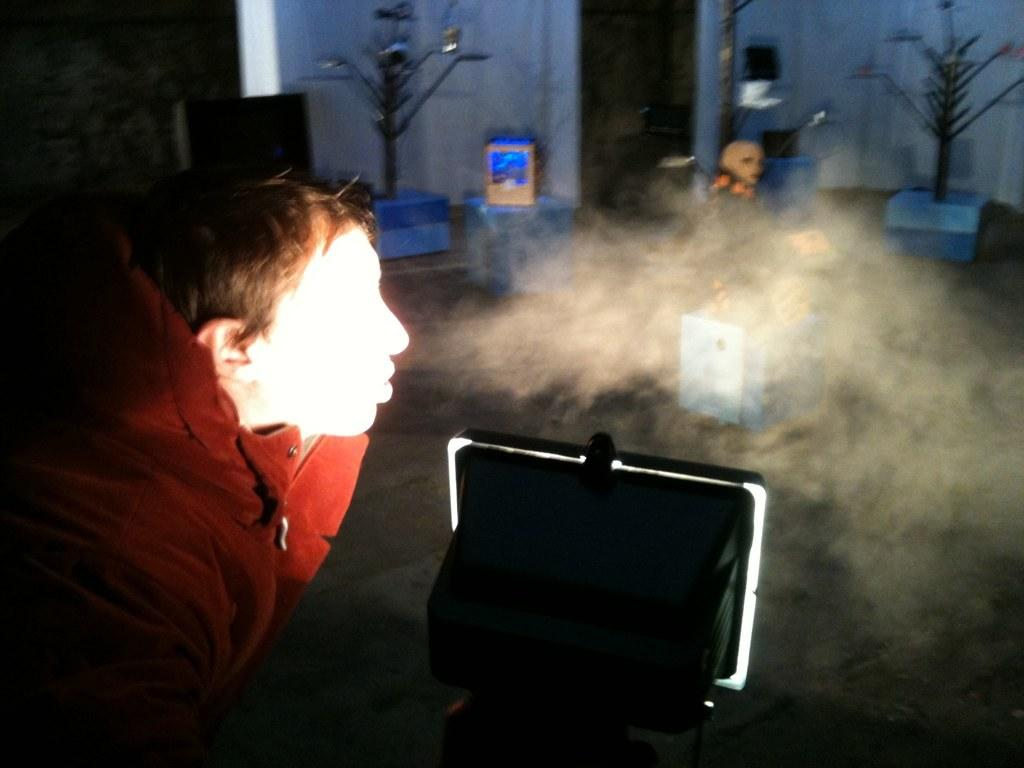Who is the main subject in the image? There is a boy in the image. What is the boy wearing? The boy is wearing a red coat. What can be seen in the middle of the image? There is light and boxes in the middle of the image. Where is the door located in the image? There is a door at the top of the image. Can you see any thumbs in the image? There are no thumbs visible in the image. Are there any icicles hanging from the door in the image? There are no icicles present in the image. 